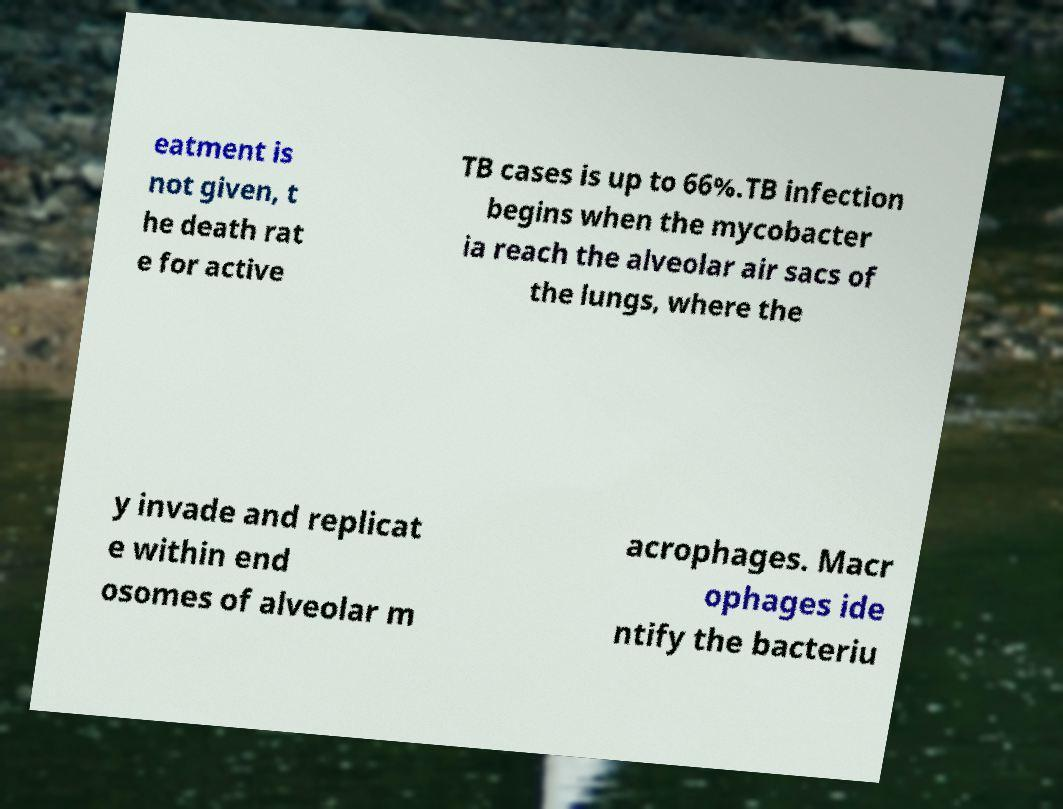Can you accurately transcribe the text from the provided image for me? eatment is not given, t he death rat e for active TB cases is up to 66%.TB infection begins when the mycobacter ia reach the alveolar air sacs of the lungs, where the y invade and replicat e within end osomes of alveolar m acrophages. Macr ophages ide ntify the bacteriu 